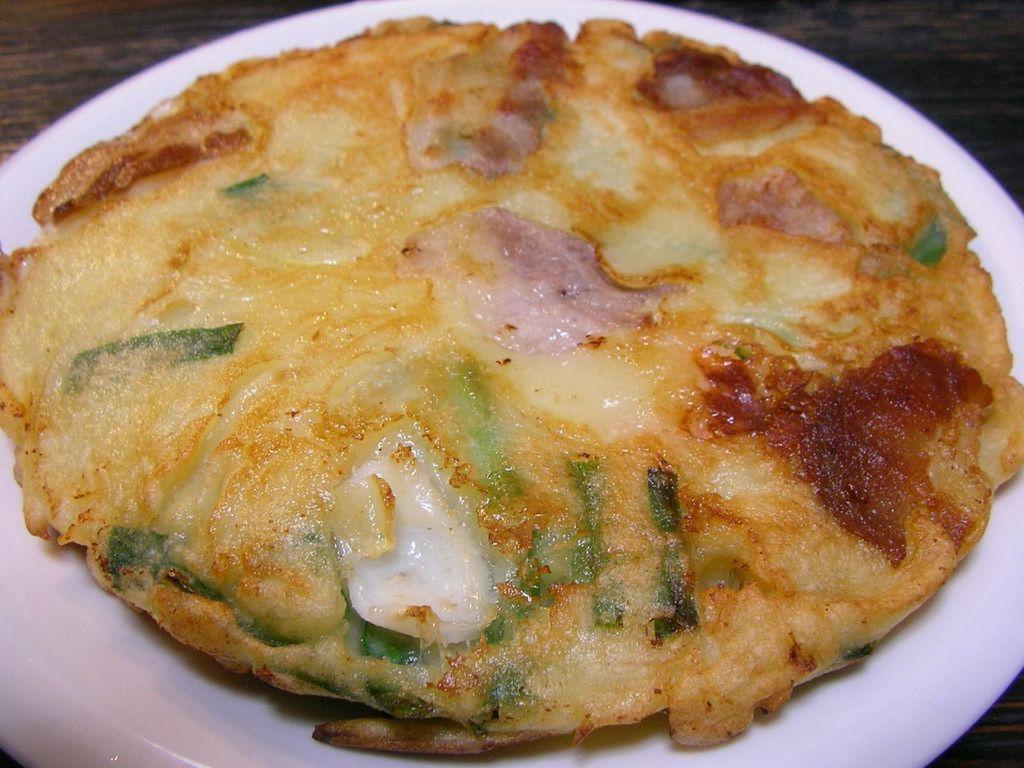Please provide a concise description of this image. In this picture we can see a pizza in the plate. 